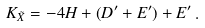<formula> <loc_0><loc_0><loc_500><loc_500>K _ { \tilde { X } } = - 4 H + ( D ^ { \prime } + E ^ { \prime } ) + E ^ { \prime } \, .</formula> 